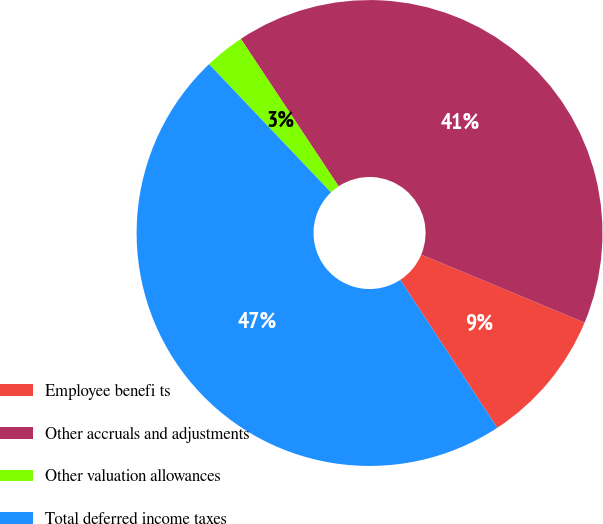<chart> <loc_0><loc_0><loc_500><loc_500><pie_chart><fcel>Employee benefi ts<fcel>Other accruals and adjustments<fcel>Other valuation allowances<fcel>Total deferred income taxes<nl><fcel>9.48%<fcel>40.6%<fcel>2.78%<fcel>47.14%<nl></chart> 